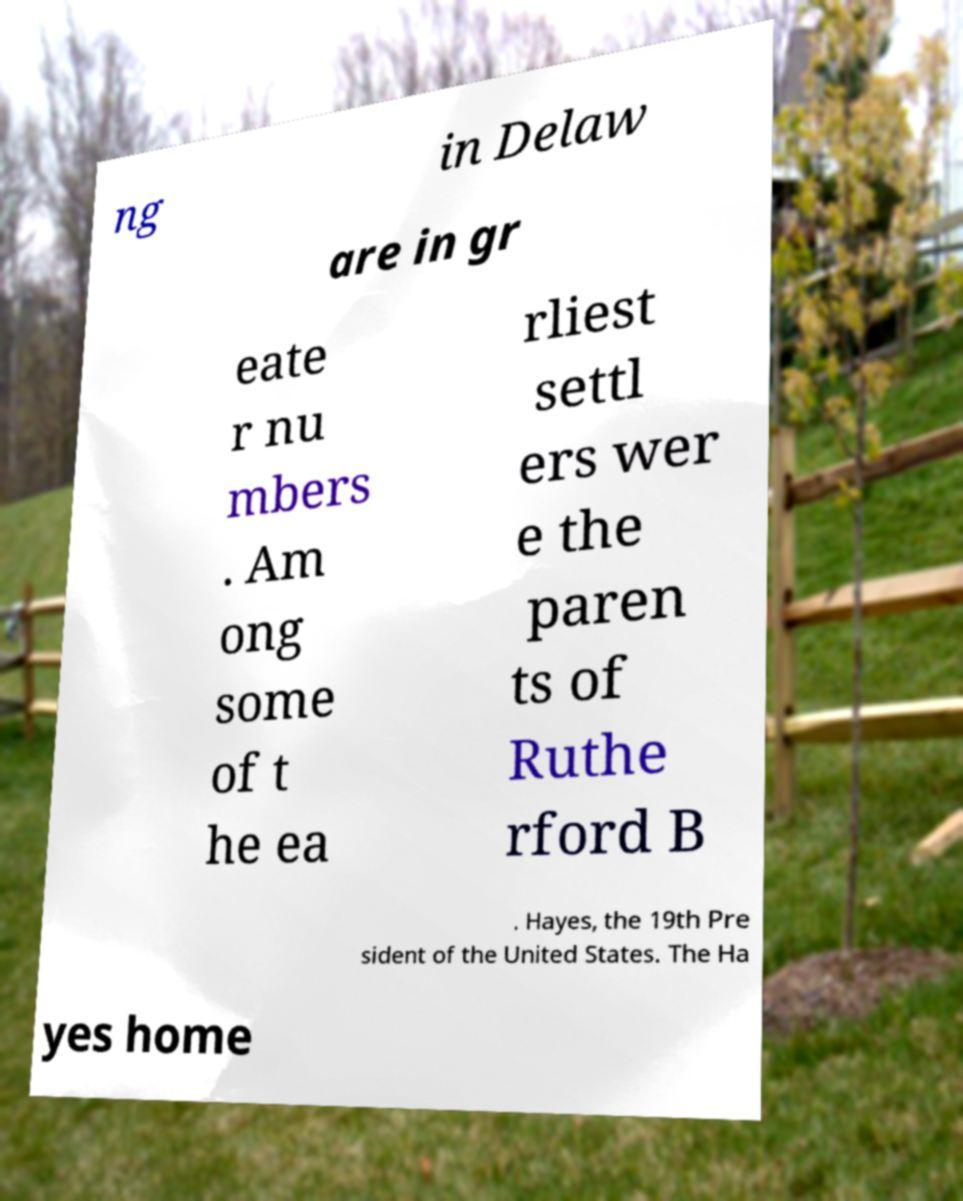Could you assist in decoding the text presented in this image and type it out clearly? ng in Delaw are in gr eate r nu mbers . Am ong some of t he ea rliest settl ers wer e the paren ts of Ruthe rford B . Hayes, the 19th Pre sident of the United States. The Ha yes home 